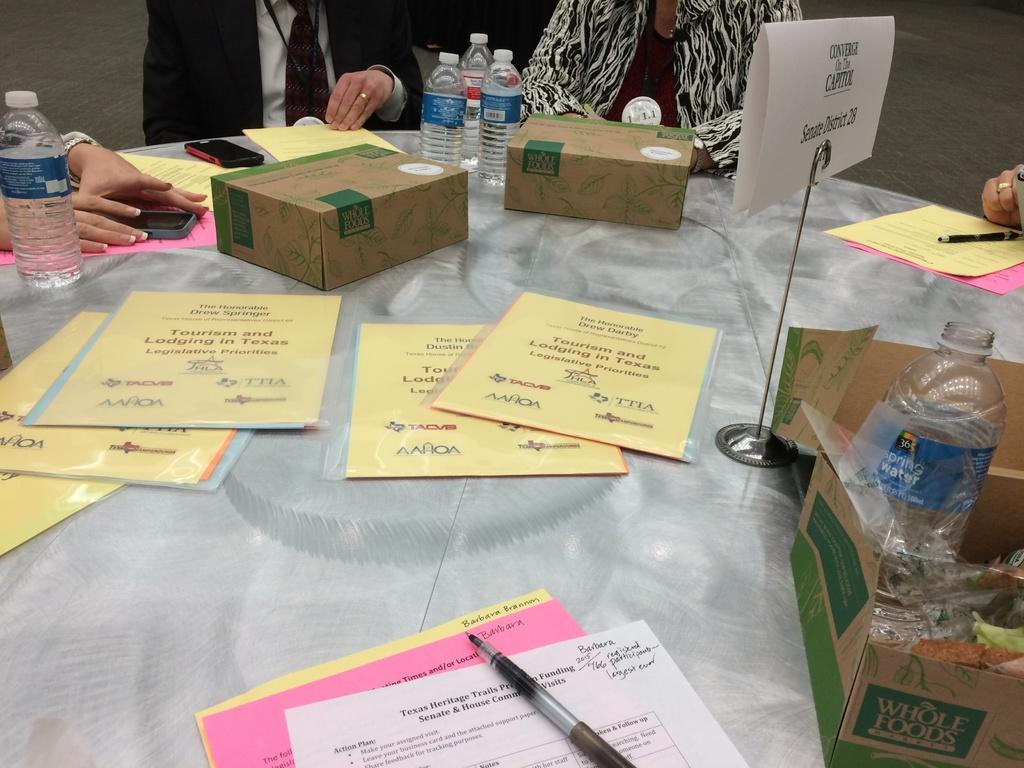How many people are in the image? There are four persons in the image. What are the persons doing in the image? The persons are sitting on chairs. What is on the table in the image? Papers, a pen, a box, a bottle, and a mobile phone are on the table. What type of friction can be seen between the persons' feet and the floor in the image? There is no information about the persons' feet or the floor in the image, so it is not possible to determine the type of friction present. 